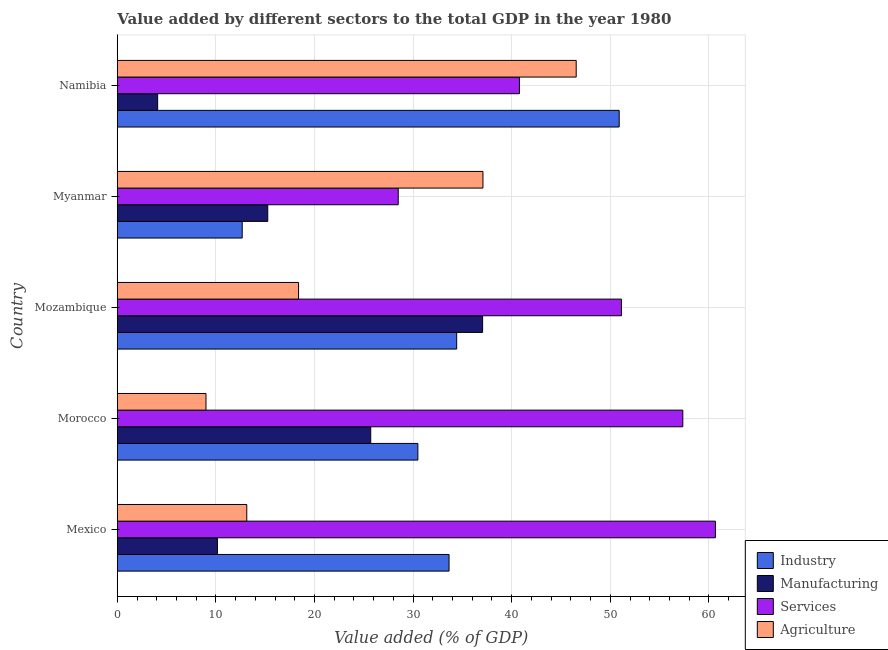How many different coloured bars are there?
Offer a very short reply. 4. Are the number of bars on each tick of the Y-axis equal?
Provide a succinct answer. Yes. How many bars are there on the 5th tick from the top?
Keep it short and to the point. 4. What is the label of the 3rd group of bars from the top?
Ensure brevity in your answer.  Mozambique. What is the value added by services sector in Morocco?
Keep it short and to the point. 57.36. Across all countries, what is the maximum value added by industrial sector?
Provide a succinct answer. 50.9. Across all countries, what is the minimum value added by industrial sector?
Your response must be concise. 12.67. In which country was the value added by manufacturing sector maximum?
Ensure brevity in your answer.  Mozambique. In which country was the value added by manufacturing sector minimum?
Offer a very short reply. Namibia. What is the total value added by agricultural sector in the graph?
Offer a very short reply. 124.14. What is the difference between the value added by services sector in Mozambique and that in Namibia?
Keep it short and to the point. 10.34. What is the difference between the value added by manufacturing sector in Mozambique and the value added by agricultural sector in Mexico?
Your response must be concise. 23.92. What is the average value added by agricultural sector per country?
Ensure brevity in your answer.  24.83. What is the difference between the value added by services sector and value added by industrial sector in Namibia?
Give a very brief answer. -10.12. In how many countries, is the value added by agricultural sector greater than 56 %?
Make the answer very short. 0. What is the ratio of the value added by industrial sector in Mexico to that in Morocco?
Your response must be concise. 1.1. Is the value added by agricultural sector in Mexico less than that in Mozambique?
Ensure brevity in your answer.  Yes. What is the difference between the highest and the second highest value added by industrial sector?
Give a very brief answer. 16.48. What is the difference between the highest and the lowest value added by agricultural sector?
Keep it short and to the point. 37.55. In how many countries, is the value added by industrial sector greater than the average value added by industrial sector taken over all countries?
Your answer should be very brief. 3. Is it the case that in every country, the sum of the value added by industrial sector and value added by manufacturing sector is greater than the sum of value added by agricultural sector and value added by services sector?
Your answer should be very brief. No. What does the 3rd bar from the top in Myanmar represents?
Your response must be concise. Manufacturing. What does the 4th bar from the bottom in Mozambique represents?
Make the answer very short. Agriculture. Is it the case that in every country, the sum of the value added by industrial sector and value added by manufacturing sector is greater than the value added by services sector?
Provide a succinct answer. No. Are all the bars in the graph horizontal?
Make the answer very short. Yes. How many countries are there in the graph?
Make the answer very short. 5. Does the graph contain any zero values?
Provide a short and direct response. No. Does the graph contain grids?
Ensure brevity in your answer.  Yes. Where does the legend appear in the graph?
Your answer should be very brief. Bottom right. What is the title of the graph?
Provide a short and direct response. Value added by different sectors to the total GDP in the year 1980. What is the label or title of the X-axis?
Your answer should be compact. Value added (% of GDP). What is the label or title of the Y-axis?
Give a very brief answer. Country. What is the Value added (% of GDP) in Industry in Mexico?
Give a very brief answer. 33.65. What is the Value added (% of GDP) in Manufacturing in Mexico?
Give a very brief answer. 10.16. What is the Value added (% of GDP) in Services in Mexico?
Offer a terse response. 60.66. What is the Value added (% of GDP) of Agriculture in Mexico?
Offer a terse response. 13.13. What is the Value added (% of GDP) of Industry in Morocco?
Your answer should be very brief. 30.49. What is the Value added (% of GDP) in Manufacturing in Morocco?
Provide a succinct answer. 25.7. What is the Value added (% of GDP) of Services in Morocco?
Give a very brief answer. 57.36. What is the Value added (% of GDP) in Agriculture in Morocco?
Keep it short and to the point. 9. What is the Value added (% of GDP) in Industry in Mozambique?
Your answer should be compact. 34.42. What is the Value added (% of GDP) of Manufacturing in Mozambique?
Keep it short and to the point. 37.05. What is the Value added (% of GDP) in Services in Mozambique?
Offer a terse response. 51.13. What is the Value added (% of GDP) of Agriculture in Mozambique?
Ensure brevity in your answer.  18.38. What is the Value added (% of GDP) in Industry in Myanmar?
Offer a terse response. 12.67. What is the Value added (% of GDP) in Manufacturing in Myanmar?
Provide a succinct answer. 15.26. What is the Value added (% of GDP) of Services in Myanmar?
Your response must be concise. 28.49. What is the Value added (% of GDP) of Agriculture in Myanmar?
Ensure brevity in your answer.  37.09. What is the Value added (% of GDP) in Industry in Namibia?
Your response must be concise. 50.9. What is the Value added (% of GDP) in Manufacturing in Namibia?
Ensure brevity in your answer.  4.09. What is the Value added (% of GDP) of Services in Namibia?
Your answer should be very brief. 40.79. What is the Value added (% of GDP) in Agriculture in Namibia?
Offer a very short reply. 46.54. Across all countries, what is the maximum Value added (% of GDP) of Industry?
Offer a very short reply. 50.9. Across all countries, what is the maximum Value added (% of GDP) in Manufacturing?
Your response must be concise. 37.05. Across all countries, what is the maximum Value added (% of GDP) of Services?
Offer a terse response. 60.66. Across all countries, what is the maximum Value added (% of GDP) of Agriculture?
Provide a short and direct response. 46.54. Across all countries, what is the minimum Value added (% of GDP) of Industry?
Your answer should be compact. 12.67. Across all countries, what is the minimum Value added (% of GDP) in Manufacturing?
Offer a very short reply. 4.09. Across all countries, what is the minimum Value added (% of GDP) of Services?
Keep it short and to the point. 28.49. Across all countries, what is the minimum Value added (% of GDP) of Agriculture?
Offer a very short reply. 9. What is the total Value added (% of GDP) in Industry in the graph?
Provide a short and direct response. 162.13. What is the total Value added (% of GDP) in Manufacturing in the graph?
Your response must be concise. 92.27. What is the total Value added (% of GDP) of Services in the graph?
Ensure brevity in your answer.  238.42. What is the total Value added (% of GDP) of Agriculture in the graph?
Provide a succinct answer. 124.14. What is the difference between the Value added (% of GDP) of Industry in Mexico and that in Morocco?
Offer a very short reply. 3.16. What is the difference between the Value added (% of GDP) of Manufacturing in Mexico and that in Morocco?
Offer a terse response. -15.55. What is the difference between the Value added (% of GDP) of Services in Mexico and that in Morocco?
Give a very brief answer. 3.31. What is the difference between the Value added (% of GDP) of Agriculture in Mexico and that in Morocco?
Provide a succinct answer. 4.14. What is the difference between the Value added (% of GDP) in Industry in Mexico and that in Mozambique?
Make the answer very short. -0.77. What is the difference between the Value added (% of GDP) in Manufacturing in Mexico and that in Mozambique?
Your answer should be compact. -26.9. What is the difference between the Value added (% of GDP) in Services in Mexico and that in Mozambique?
Ensure brevity in your answer.  9.53. What is the difference between the Value added (% of GDP) of Agriculture in Mexico and that in Mozambique?
Your answer should be compact. -5.25. What is the difference between the Value added (% of GDP) in Industry in Mexico and that in Myanmar?
Your answer should be very brief. 20.98. What is the difference between the Value added (% of GDP) of Manufacturing in Mexico and that in Myanmar?
Make the answer very short. -5.1. What is the difference between the Value added (% of GDP) of Services in Mexico and that in Myanmar?
Provide a short and direct response. 32.17. What is the difference between the Value added (% of GDP) of Agriculture in Mexico and that in Myanmar?
Your response must be concise. -23.95. What is the difference between the Value added (% of GDP) of Industry in Mexico and that in Namibia?
Make the answer very short. -17.26. What is the difference between the Value added (% of GDP) of Manufacturing in Mexico and that in Namibia?
Offer a very short reply. 6.06. What is the difference between the Value added (% of GDP) of Services in Mexico and that in Namibia?
Offer a very short reply. 19.88. What is the difference between the Value added (% of GDP) in Agriculture in Mexico and that in Namibia?
Provide a short and direct response. -33.41. What is the difference between the Value added (% of GDP) of Industry in Morocco and that in Mozambique?
Offer a very short reply. -3.94. What is the difference between the Value added (% of GDP) in Manufacturing in Morocco and that in Mozambique?
Your response must be concise. -11.35. What is the difference between the Value added (% of GDP) of Services in Morocco and that in Mozambique?
Give a very brief answer. 6.23. What is the difference between the Value added (% of GDP) in Agriculture in Morocco and that in Mozambique?
Your answer should be compact. -9.39. What is the difference between the Value added (% of GDP) in Industry in Morocco and that in Myanmar?
Offer a terse response. 17.81. What is the difference between the Value added (% of GDP) in Manufacturing in Morocco and that in Myanmar?
Offer a terse response. 10.44. What is the difference between the Value added (% of GDP) in Services in Morocco and that in Myanmar?
Your answer should be very brief. 28.86. What is the difference between the Value added (% of GDP) in Agriculture in Morocco and that in Myanmar?
Provide a short and direct response. -28.09. What is the difference between the Value added (% of GDP) in Industry in Morocco and that in Namibia?
Offer a very short reply. -20.42. What is the difference between the Value added (% of GDP) in Manufacturing in Morocco and that in Namibia?
Provide a succinct answer. 21.61. What is the difference between the Value added (% of GDP) in Services in Morocco and that in Namibia?
Offer a very short reply. 16.57. What is the difference between the Value added (% of GDP) of Agriculture in Morocco and that in Namibia?
Provide a short and direct response. -37.55. What is the difference between the Value added (% of GDP) in Industry in Mozambique and that in Myanmar?
Ensure brevity in your answer.  21.75. What is the difference between the Value added (% of GDP) of Manufacturing in Mozambique and that in Myanmar?
Your response must be concise. 21.79. What is the difference between the Value added (% of GDP) in Services in Mozambique and that in Myanmar?
Your response must be concise. 22.64. What is the difference between the Value added (% of GDP) in Agriculture in Mozambique and that in Myanmar?
Provide a succinct answer. -18.7. What is the difference between the Value added (% of GDP) in Industry in Mozambique and that in Namibia?
Make the answer very short. -16.48. What is the difference between the Value added (% of GDP) in Manufacturing in Mozambique and that in Namibia?
Ensure brevity in your answer.  32.96. What is the difference between the Value added (% of GDP) in Services in Mozambique and that in Namibia?
Ensure brevity in your answer.  10.34. What is the difference between the Value added (% of GDP) in Agriculture in Mozambique and that in Namibia?
Make the answer very short. -28.16. What is the difference between the Value added (% of GDP) in Industry in Myanmar and that in Namibia?
Ensure brevity in your answer.  -38.23. What is the difference between the Value added (% of GDP) of Manufacturing in Myanmar and that in Namibia?
Ensure brevity in your answer.  11.17. What is the difference between the Value added (% of GDP) in Services in Myanmar and that in Namibia?
Give a very brief answer. -12.29. What is the difference between the Value added (% of GDP) in Agriculture in Myanmar and that in Namibia?
Keep it short and to the point. -9.46. What is the difference between the Value added (% of GDP) of Industry in Mexico and the Value added (% of GDP) of Manufacturing in Morocco?
Offer a very short reply. 7.94. What is the difference between the Value added (% of GDP) in Industry in Mexico and the Value added (% of GDP) in Services in Morocco?
Your response must be concise. -23.71. What is the difference between the Value added (% of GDP) in Industry in Mexico and the Value added (% of GDP) in Agriculture in Morocco?
Ensure brevity in your answer.  24.65. What is the difference between the Value added (% of GDP) in Manufacturing in Mexico and the Value added (% of GDP) in Services in Morocco?
Your answer should be very brief. -47.2. What is the difference between the Value added (% of GDP) of Manufacturing in Mexico and the Value added (% of GDP) of Agriculture in Morocco?
Make the answer very short. 1.16. What is the difference between the Value added (% of GDP) in Services in Mexico and the Value added (% of GDP) in Agriculture in Morocco?
Your answer should be compact. 51.67. What is the difference between the Value added (% of GDP) in Industry in Mexico and the Value added (% of GDP) in Manufacturing in Mozambique?
Make the answer very short. -3.4. What is the difference between the Value added (% of GDP) of Industry in Mexico and the Value added (% of GDP) of Services in Mozambique?
Ensure brevity in your answer.  -17.48. What is the difference between the Value added (% of GDP) in Industry in Mexico and the Value added (% of GDP) in Agriculture in Mozambique?
Provide a short and direct response. 15.26. What is the difference between the Value added (% of GDP) in Manufacturing in Mexico and the Value added (% of GDP) in Services in Mozambique?
Offer a terse response. -40.97. What is the difference between the Value added (% of GDP) in Manufacturing in Mexico and the Value added (% of GDP) in Agriculture in Mozambique?
Ensure brevity in your answer.  -8.23. What is the difference between the Value added (% of GDP) in Services in Mexico and the Value added (% of GDP) in Agriculture in Mozambique?
Your answer should be compact. 42.28. What is the difference between the Value added (% of GDP) of Industry in Mexico and the Value added (% of GDP) of Manufacturing in Myanmar?
Give a very brief answer. 18.39. What is the difference between the Value added (% of GDP) of Industry in Mexico and the Value added (% of GDP) of Services in Myanmar?
Your response must be concise. 5.16. What is the difference between the Value added (% of GDP) in Industry in Mexico and the Value added (% of GDP) in Agriculture in Myanmar?
Give a very brief answer. -3.44. What is the difference between the Value added (% of GDP) of Manufacturing in Mexico and the Value added (% of GDP) of Services in Myanmar?
Provide a succinct answer. -18.34. What is the difference between the Value added (% of GDP) in Manufacturing in Mexico and the Value added (% of GDP) in Agriculture in Myanmar?
Offer a terse response. -26.93. What is the difference between the Value added (% of GDP) in Services in Mexico and the Value added (% of GDP) in Agriculture in Myanmar?
Your answer should be very brief. 23.58. What is the difference between the Value added (% of GDP) in Industry in Mexico and the Value added (% of GDP) in Manufacturing in Namibia?
Ensure brevity in your answer.  29.55. What is the difference between the Value added (% of GDP) of Industry in Mexico and the Value added (% of GDP) of Services in Namibia?
Your answer should be very brief. -7.14. What is the difference between the Value added (% of GDP) in Industry in Mexico and the Value added (% of GDP) in Agriculture in Namibia?
Make the answer very short. -12.89. What is the difference between the Value added (% of GDP) of Manufacturing in Mexico and the Value added (% of GDP) of Services in Namibia?
Offer a very short reply. -30.63. What is the difference between the Value added (% of GDP) in Manufacturing in Mexico and the Value added (% of GDP) in Agriculture in Namibia?
Ensure brevity in your answer.  -36.39. What is the difference between the Value added (% of GDP) of Services in Mexico and the Value added (% of GDP) of Agriculture in Namibia?
Ensure brevity in your answer.  14.12. What is the difference between the Value added (% of GDP) in Industry in Morocco and the Value added (% of GDP) in Manufacturing in Mozambique?
Provide a short and direct response. -6.57. What is the difference between the Value added (% of GDP) in Industry in Morocco and the Value added (% of GDP) in Services in Mozambique?
Give a very brief answer. -20.64. What is the difference between the Value added (% of GDP) in Industry in Morocco and the Value added (% of GDP) in Agriculture in Mozambique?
Your answer should be compact. 12.1. What is the difference between the Value added (% of GDP) of Manufacturing in Morocco and the Value added (% of GDP) of Services in Mozambique?
Keep it short and to the point. -25.43. What is the difference between the Value added (% of GDP) of Manufacturing in Morocco and the Value added (% of GDP) of Agriculture in Mozambique?
Keep it short and to the point. 7.32. What is the difference between the Value added (% of GDP) of Services in Morocco and the Value added (% of GDP) of Agriculture in Mozambique?
Keep it short and to the point. 38.97. What is the difference between the Value added (% of GDP) in Industry in Morocco and the Value added (% of GDP) in Manufacturing in Myanmar?
Make the answer very short. 15.22. What is the difference between the Value added (% of GDP) in Industry in Morocco and the Value added (% of GDP) in Services in Myanmar?
Make the answer very short. 1.99. What is the difference between the Value added (% of GDP) in Industry in Morocco and the Value added (% of GDP) in Agriculture in Myanmar?
Offer a very short reply. -6.6. What is the difference between the Value added (% of GDP) of Manufacturing in Morocco and the Value added (% of GDP) of Services in Myanmar?
Provide a short and direct response. -2.79. What is the difference between the Value added (% of GDP) in Manufacturing in Morocco and the Value added (% of GDP) in Agriculture in Myanmar?
Offer a terse response. -11.38. What is the difference between the Value added (% of GDP) of Services in Morocco and the Value added (% of GDP) of Agriculture in Myanmar?
Keep it short and to the point. 20.27. What is the difference between the Value added (% of GDP) in Industry in Morocco and the Value added (% of GDP) in Manufacturing in Namibia?
Provide a short and direct response. 26.39. What is the difference between the Value added (% of GDP) in Industry in Morocco and the Value added (% of GDP) in Services in Namibia?
Your answer should be very brief. -10.3. What is the difference between the Value added (% of GDP) of Industry in Morocco and the Value added (% of GDP) of Agriculture in Namibia?
Your answer should be compact. -16.06. What is the difference between the Value added (% of GDP) of Manufacturing in Morocco and the Value added (% of GDP) of Services in Namibia?
Keep it short and to the point. -15.08. What is the difference between the Value added (% of GDP) of Manufacturing in Morocco and the Value added (% of GDP) of Agriculture in Namibia?
Your response must be concise. -20.84. What is the difference between the Value added (% of GDP) of Services in Morocco and the Value added (% of GDP) of Agriculture in Namibia?
Offer a terse response. 10.81. What is the difference between the Value added (% of GDP) in Industry in Mozambique and the Value added (% of GDP) in Manufacturing in Myanmar?
Your answer should be compact. 19.16. What is the difference between the Value added (% of GDP) in Industry in Mozambique and the Value added (% of GDP) in Services in Myanmar?
Make the answer very short. 5.93. What is the difference between the Value added (% of GDP) of Industry in Mozambique and the Value added (% of GDP) of Agriculture in Myanmar?
Keep it short and to the point. -2.66. What is the difference between the Value added (% of GDP) in Manufacturing in Mozambique and the Value added (% of GDP) in Services in Myanmar?
Offer a very short reply. 8.56. What is the difference between the Value added (% of GDP) in Manufacturing in Mozambique and the Value added (% of GDP) in Agriculture in Myanmar?
Your response must be concise. -0.03. What is the difference between the Value added (% of GDP) in Services in Mozambique and the Value added (% of GDP) in Agriculture in Myanmar?
Your answer should be very brief. 14.04. What is the difference between the Value added (% of GDP) of Industry in Mozambique and the Value added (% of GDP) of Manufacturing in Namibia?
Make the answer very short. 30.33. What is the difference between the Value added (% of GDP) in Industry in Mozambique and the Value added (% of GDP) in Services in Namibia?
Provide a short and direct response. -6.36. What is the difference between the Value added (% of GDP) in Industry in Mozambique and the Value added (% of GDP) in Agriculture in Namibia?
Your answer should be very brief. -12.12. What is the difference between the Value added (% of GDP) of Manufacturing in Mozambique and the Value added (% of GDP) of Services in Namibia?
Your response must be concise. -3.73. What is the difference between the Value added (% of GDP) in Manufacturing in Mozambique and the Value added (% of GDP) in Agriculture in Namibia?
Offer a very short reply. -9.49. What is the difference between the Value added (% of GDP) in Services in Mozambique and the Value added (% of GDP) in Agriculture in Namibia?
Give a very brief answer. 4.59. What is the difference between the Value added (% of GDP) of Industry in Myanmar and the Value added (% of GDP) of Manufacturing in Namibia?
Offer a terse response. 8.58. What is the difference between the Value added (% of GDP) in Industry in Myanmar and the Value added (% of GDP) in Services in Namibia?
Give a very brief answer. -28.12. What is the difference between the Value added (% of GDP) of Industry in Myanmar and the Value added (% of GDP) of Agriculture in Namibia?
Your response must be concise. -33.87. What is the difference between the Value added (% of GDP) in Manufacturing in Myanmar and the Value added (% of GDP) in Services in Namibia?
Provide a succinct answer. -25.53. What is the difference between the Value added (% of GDP) of Manufacturing in Myanmar and the Value added (% of GDP) of Agriculture in Namibia?
Your response must be concise. -31.28. What is the difference between the Value added (% of GDP) in Services in Myanmar and the Value added (% of GDP) in Agriculture in Namibia?
Provide a short and direct response. -18.05. What is the average Value added (% of GDP) in Industry per country?
Your answer should be very brief. 32.43. What is the average Value added (% of GDP) in Manufacturing per country?
Provide a succinct answer. 18.45. What is the average Value added (% of GDP) in Services per country?
Give a very brief answer. 47.69. What is the average Value added (% of GDP) in Agriculture per country?
Offer a terse response. 24.83. What is the difference between the Value added (% of GDP) of Industry and Value added (% of GDP) of Manufacturing in Mexico?
Keep it short and to the point. 23.49. What is the difference between the Value added (% of GDP) in Industry and Value added (% of GDP) in Services in Mexico?
Give a very brief answer. -27.01. What is the difference between the Value added (% of GDP) of Industry and Value added (% of GDP) of Agriculture in Mexico?
Offer a very short reply. 20.52. What is the difference between the Value added (% of GDP) in Manufacturing and Value added (% of GDP) in Services in Mexico?
Provide a short and direct response. -50.51. What is the difference between the Value added (% of GDP) in Manufacturing and Value added (% of GDP) in Agriculture in Mexico?
Offer a very short reply. -2.98. What is the difference between the Value added (% of GDP) in Services and Value added (% of GDP) in Agriculture in Mexico?
Give a very brief answer. 47.53. What is the difference between the Value added (% of GDP) of Industry and Value added (% of GDP) of Manufacturing in Morocco?
Provide a short and direct response. 4.78. What is the difference between the Value added (% of GDP) in Industry and Value added (% of GDP) in Services in Morocco?
Offer a terse response. -26.87. What is the difference between the Value added (% of GDP) in Industry and Value added (% of GDP) in Agriculture in Morocco?
Keep it short and to the point. 21.49. What is the difference between the Value added (% of GDP) in Manufacturing and Value added (% of GDP) in Services in Morocco?
Provide a succinct answer. -31.65. What is the difference between the Value added (% of GDP) of Manufacturing and Value added (% of GDP) of Agriculture in Morocco?
Keep it short and to the point. 16.71. What is the difference between the Value added (% of GDP) in Services and Value added (% of GDP) in Agriculture in Morocco?
Give a very brief answer. 48.36. What is the difference between the Value added (% of GDP) in Industry and Value added (% of GDP) in Manufacturing in Mozambique?
Provide a succinct answer. -2.63. What is the difference between the Value added (% of GDP) in Industry and Value added (% of GDP) in Services in Mozambique?
Make the answer very short. -16.71. What is the difference between the Value added (% of GDP) in Industry and Value added (% of GDP) in Agriculture in Mozambique?
Provide a short and direct response. 16.04. What is the difference between the Value added (% of GDP) in Manufacturing and Value added (% of GDP) in Services in Mozambique?
Keep it short and to the point. -14.08. What is the difference between the Value added (% of GDP) of Manufacturing and Value added (% of GDP) of Agriculture in Mozambique?
Ensure brevity in your answer.  18.67. What is the difference between the Value added (% of GDP) of Services and Value added (% of GDP) of Agriculture in Mozambique?
Ensure brevity in your answer.  32.74. What is the difference between the Value added (% of GDP) in Industry and Value added (% of GDP) in Manufacturing in Myanmar?
Your answer should be compact. -2.59. What is the difference between the Value added (% of GDP) in Industry and Value added (% of GDP) in Services in Myanmar?
Offer a very short reply. -15.82. What is the difference between the Value added (% of GDP) in Industry and Value added (% of GDP) in Agriculture in Myanmar?
Your answer should be very brief. -24.41. What is the difference between the Value added (% of GDP) in Manufacturing and Value added (% of GDP) in Services in Myanmar?
Keep it short and to the point. -13.23. What is the difference between the Value added (% of GDP) of Manufacturing and Value added (% of GDP) of Agriculture in Myanmar?
Offer a terse response. -21.82. What is the difference between the Value added (% of GDP) in Services and Value added (% of GDP) in Agriculture in Myanmar?
Provide a short and direct response. -8.59. What is the difference between the Value added (% of GDP) in Industry and Value added (% of GDP) in Manufacturing in Namibia?
Your response must be concise. 46.81. What is the difference between the Value added (% of GDP) in Industry and Value added (% of GDP) in Services in Namibia?
Offer a terse response. 10.12. What is the difference between the Value added (% of GDP) of Industry and Value added (% of GDP) of Agriculture in Namibia?
Provide a succinct answer. 4.36. What is the difference between the Value added (% of GDP) in Manufacturing and Value added (% of GDP) in Services in Namibia?
Give a very brief answer. -36.69. What is the difference between the Value added (% of GDP) in Manufacturing and Value added (% of GDP) in Agriculture in Namibia?
Keep it short and to the point. -42.45. What is the difference between the Value added (% of GDP) in Services and Value added (% of GDP) in Agriculture in Namibia?
Make the answer very short. -5.76. What is the ratio of the Value added (% of GDP) in Industry in Mexico to that in Morocco?
Make the answer very short. 1.1. What is the ratio of the Value added (% of GDP) of Manufacturing in Mexico to that in Morocco?
Provide a succinct answer. 0.4. What is the ratio of the Value added (% of GDP) of Services in Mexico to that in Morocco?
Make the answer very short. 1.06. What is the ratio of the Value added (% of GDP) of Agriculture in Mexico to that in Morocco?
Offer a very short reply. 1.46. What is the ratio of the Value added (% of GDP) of Industry in Mexico to that in Mozambique?
Provide a succinct answer. 0.98. What is the ratio of the Value added (% of GDP) in Manufacturing in Mexico to that in Mozambique?
Make the answer very short. 0.27. What is the ratio of the Value added (% of GDP) of Services in Mexico to that in Mozambique?
Provide a succinct answer. 1.19. What is the ratio of the Value added (% of GDP) in Industry in Mexico to that in Myanmar?
Offer a very short reply. 2.66. What is the ratio of the Value added (% of GDP) in Manufacturing in Mexico to that in Myanmar?
Your answer should be compact. 0.67. What is the ratio of the Value added (% of GDP) in Services in Mexico to that in Myanmar?
Your answer should be compact. 2.13. What is the ratio of the Value added (% of GDP) in Agriculture in Mexico to that in Myanmar?
Ensure brevity in your answer.  0.35. What is the ratio of the Value added (% of GDP) in Industry in Mexico to that in Namibia?
Make the answer very short. 0.66. What is the ratio of the Value added (% of GDP) of Manufacturing in Mexico to that in Namibia?
Provide a short and direct response. 2.48. What is the ratio of the Value added (% of GDP) of Services in Mexico to that in Namibia?
Keep it short and to the point. 1.49. What is the ratio of the Value added (% of GDP) of Agriculture in Mexico to that in Namibia?
Keep it short and to the point. 0.28. What is the ratio of the Value added (% of GDP) in Industry in Morocco to that in Mozambique?
Offer a terse response. 0.89. What is the ratio of the Value added (% of GDP) in Manufacturing in Morocco to that in Mozambique?
Keep it short and to the point. 0.69. What is the ratio of the Value added (% of GDP) of Services in Morocco to that in Mozambique?
Provide a succinct answer. 1.12. What is the ratio of the Value added (% of GDP) of Agriculture in Morocco to that in Mozambique?
Your response must be concise. 0.49. What is the ratio of the Value added (% of GDP) of Industry in Morocco to that in Myanmar?
Ensure brevity in your answer.  2.41. What is the ratio of the Value added (% of GDP) of Manufacturing in Morocco to that in Myanmar?
Offer a terse response. 1.68. What is the ratio of the Value added (% of GDP) in Services in Morocco to that in Myanmar?
Offer a very short reply. 2.01. What is the ratio of the Value added (% of GDP) in Agriculture in Morocco to that in Myanmar?
Give a very brief answer. 0.24. What is the ratio of the Value added (% of GDP) of Industry in Morocco to that in Namibia?
Your response must be concise. 0.6. What is the ratio of the Value added (% of GDP) of Manufacturing in Morocco to that in Namibia?
Provide a short and direct response. 6.28. What is the ratio of the Value added (% of GDP) in Services in Morocco to that in Namibia?
Your response must be concise. 1.41. What is the ratio of the Value added (% of GDP) in Agriculture in Morocco to that in Namibia?
Your response must be concise. 0.19. What is the ratio of the Value added (% of GDP) of Industry in Mozambique to that in Myanmar?
Keep it short and to the point. 2.72. What is the ratio of the Value added (% of GDP) in Manufacturing in Mozambique to that in Myanmar?
Ensure brevity in your answer.  2.43. What is the ratio of the Value added (% of GDP) in Services in Mozambique to that in Myanmar?
Offer a terse response. 1.79. What is the ratio of the Value added (% of GDP) of Agriculture in Mozambique to that in Myanmar?
Keep it short and to the point. 0.5. What is the ratio of the Value added (% of GDP) of Industry in Mozambique to that in Namibia?
Keep it short and to the point. 0.68. What is the ratio of the Value added (% of GDP) of Manufacturing in Mozambique to that in Namibia?
Your response must be concise. 9.05. What is the ratio of the Value added (% of GDP) in Services in Mozambique to that in Namibia?
Your answer should be very brief. 1.25. What is the ratio of the Value added (% of GDP) of Agriculture in Mozambique to that in Namibia?
Provide a short and direct response. 0.4. What is the ratio of the Value added (% of GDP) in Industry in Myanmar to that in Namibia?
Your answer should be very brief. 0.25. What is the ratio of the Value added (% of GDP) of Manufacturing in Myanmar to that in Namibia?
Your response must be concise. 3.73. What is the ratio of the Value added (% of GDP) in Services in Myanmar to that in Namibia?
Keep it short and to the point. 0.7. What is the ratio of the Value added (% of GDP) in Agriculture in Myanmar to that in Namibia?
Give a very brief answer. 0.8. What is the difference between the highest and the second highest Value added (% of GDP) in Industry?
Provide a succinct answer. 16.48. What is the difference between the highest and the second highest Value added (% of GDP) of Manufacturing?
Offer a terse response. 11.35. What is the difference between the highest and the second highest Value added (% of GDP) in Services?
Ensure brevity in your answer.  3.31. What is the difference between the highest and the second highest Value added (% of GDP) in Agriculture?
Your answer should be compact. 9.46. What is the difference between the highest and the lowest Value added (% of GDP) in Industry?
Your answer should be very brief. 38.23. What is the difference between the highest and the lowest Value added (% of GDP) in Manufacturing?
Your answer should be compact. 32.96. What is the difference between the highest and the lowest Value added (% of GDP) in Services?
Provide a succinct answer. 32.17. What is the difference between the highest and the lowest Value added (% of GDP) of Agriculture?
Offer a terse response. 37.55. 